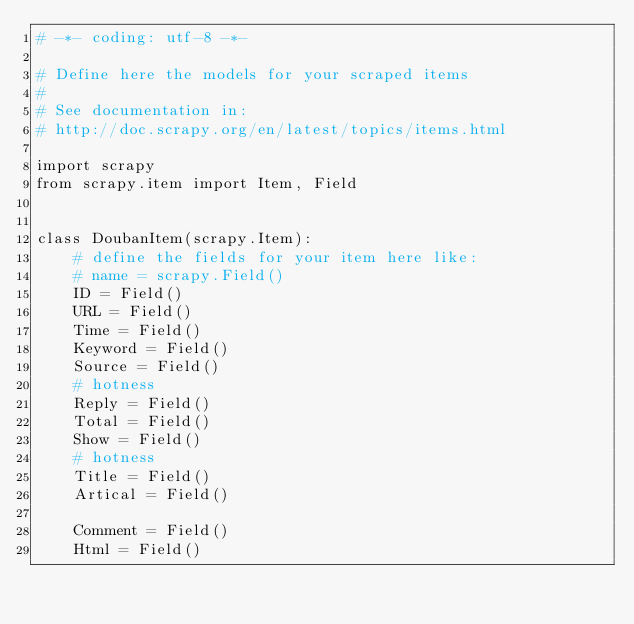<code> <loc_0><loc_0><loc_500><loc_500><_Python_># -*- coding: utf-8 -*-

# Define here the models for your scraped items
#
# See documentation in:
# http://doc.scrapy.org/en/latest/topics/items.html

import scrapy
from scrapy.item import Item, Field


class DoubanItem(scrapy.Item):
    # define the fields for your item here like:
    # name = scrapy.Field()
    ID = Field()
    URL = Field()
    Time = Field()
    Keyword = Field()
    Source = Field()
    # hotness
    Reply = Field()
    Total = Field()
    Show = Field()
    # hotness
    Title = Field()
    Artical = Field()

    Comment = Field()
    Html = Field()
</code> 